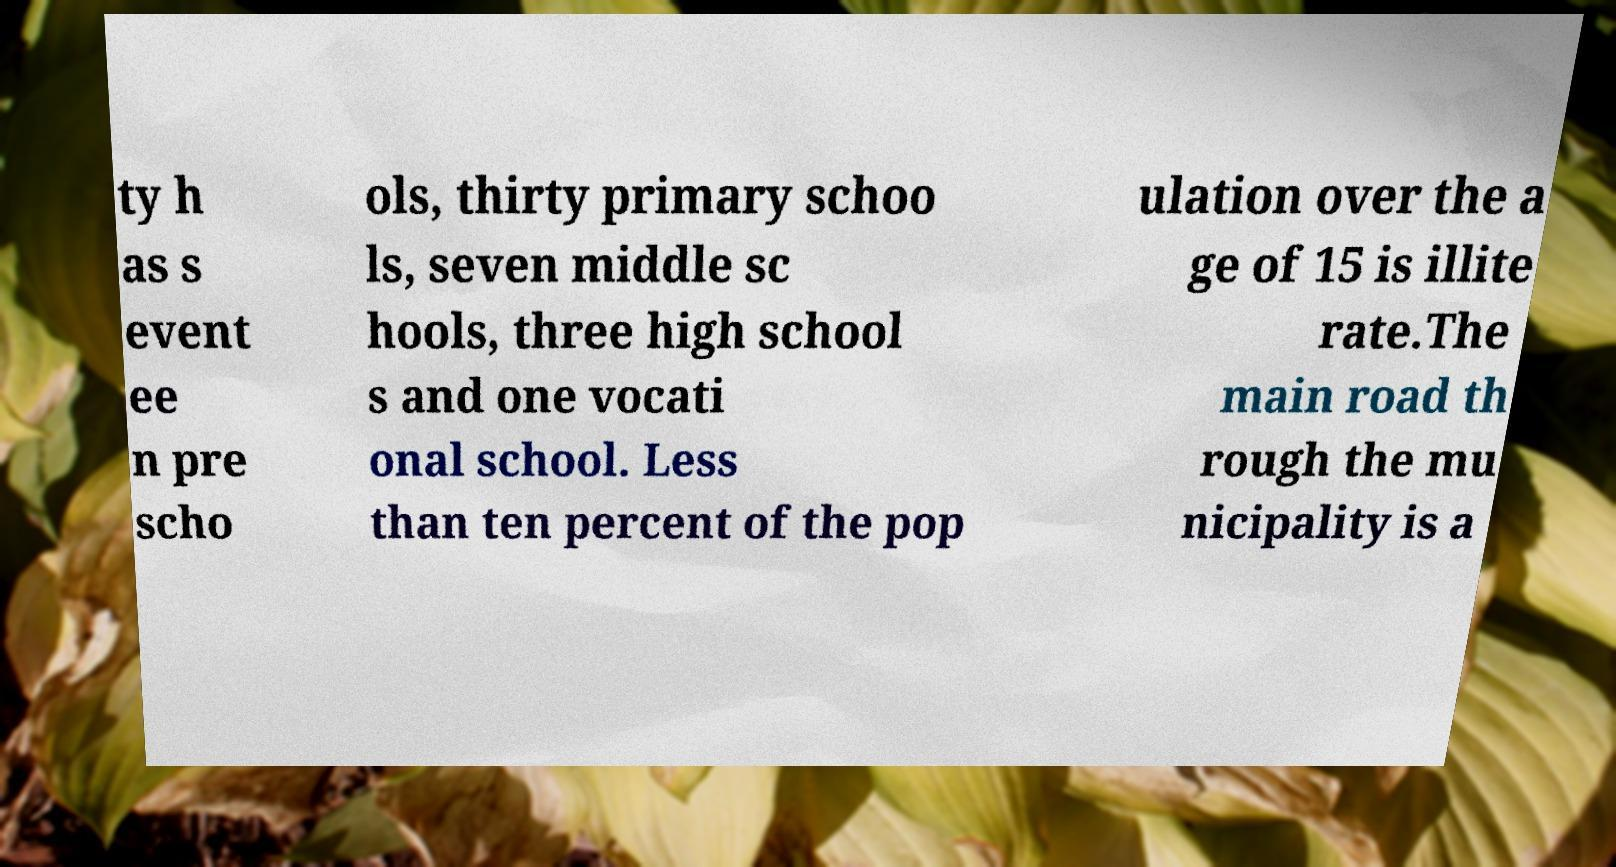Could you assist in decoding the text presented in this image and type it out clearly? ty h as s event ee n pre scho ols, thirty primary schoo ls, seven middle sc hools, three high school s and one vocati onal school. Less than ten percent of the pop ulation over the a ge of 15 is illite rate.The main road th rough the mu nicipality is a 